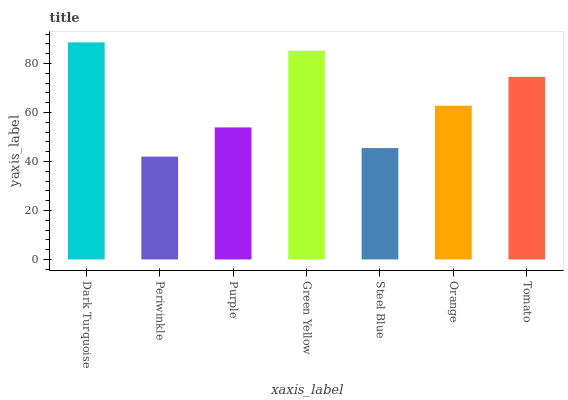Is Periwinkle the minimum?
Answer yes or no. Yes. Is Dark Turquoise the maximum?
Answer yes or no. Yes. Is Purple the minimum?
Answer yes or no. No. Is Purple the maximum?
Answer yes or no. No. Is Purple greater than Periwinkle?
Answer yes or no. Yes. Is Periwinkle less than Purple?
Answer yes or no. Yes. Is Periwinkle greater than Purple?
Answer yes or no. No. Is Purple less than Periwinkle?
Answer yes or no. No. Is Orange the high median?
Answer yes or no. Yes. Is Orange the low median?
Answer yes or no. Yes. Is Periwinkle the high median?
Answer yes or no. No. Is Dark Turquoise the low median?
Answer yes or no. No. 